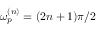Convert formula to latex. <formula><loc_0><loc_0><loc_500><loc_500>\omega _ { p } ^ { ( n ) } = ( 2 n + 1 ) \pi / 2</formula> 